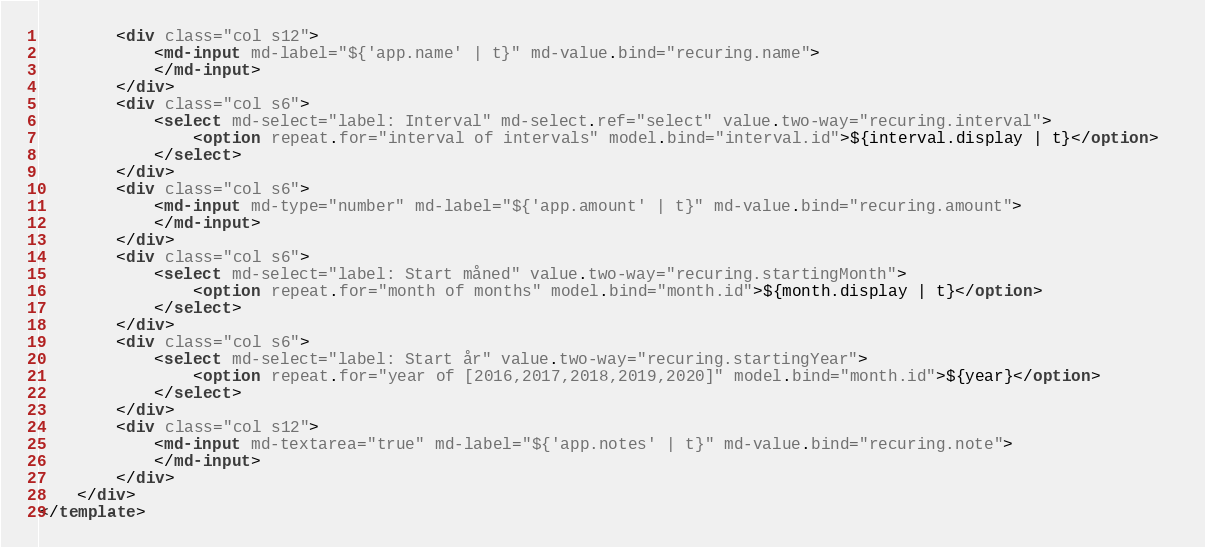<code> <loc_0><loc_0><loc_500><loc_500><_HTML_>		<div class="col s12">
			<md-input md-label="${'app.name' | t}" md-value.bind="recuring.name">
			</md-input>
		</div>
		<div class="col s6">
            <select md-select="label: Interval" md-select.ref="select" value.two-way="recuring.interval">
                <option repeat.for="interval of intervals" model.bind="interval.id">${interval.display | t}</option>  
            </select>
		</div>
		<div class="col s6">
			<md-input md-type="number" md-label="${'app.amount' | t}" md-value.bind="recuring.amount">
			</md-input>
		</div>
		<div class="col s6">
            <select md-select="label: Start måned" value.two-way="recuring.startingMonth">
                <option repeat.for="month of months" model.bind="month.id">${month.display | t}</option>  
            </select>
		</div>
		<div class="col s6">
            <select md-select="label: Start år" value.two-way="recuring.startingYear">
                <option repeat.for="year of [2016,2017,2018,2019,2020]" model.bind="month.id">${year}</option>  
            </select>
		</div>
		<div class="col s12">
			<md-input md-textarea="true" md-label="${'app.notes' | t}" md-value.bind="recuring.note">
			</md-input>
		</div>
	</div>
</template>
</code> 